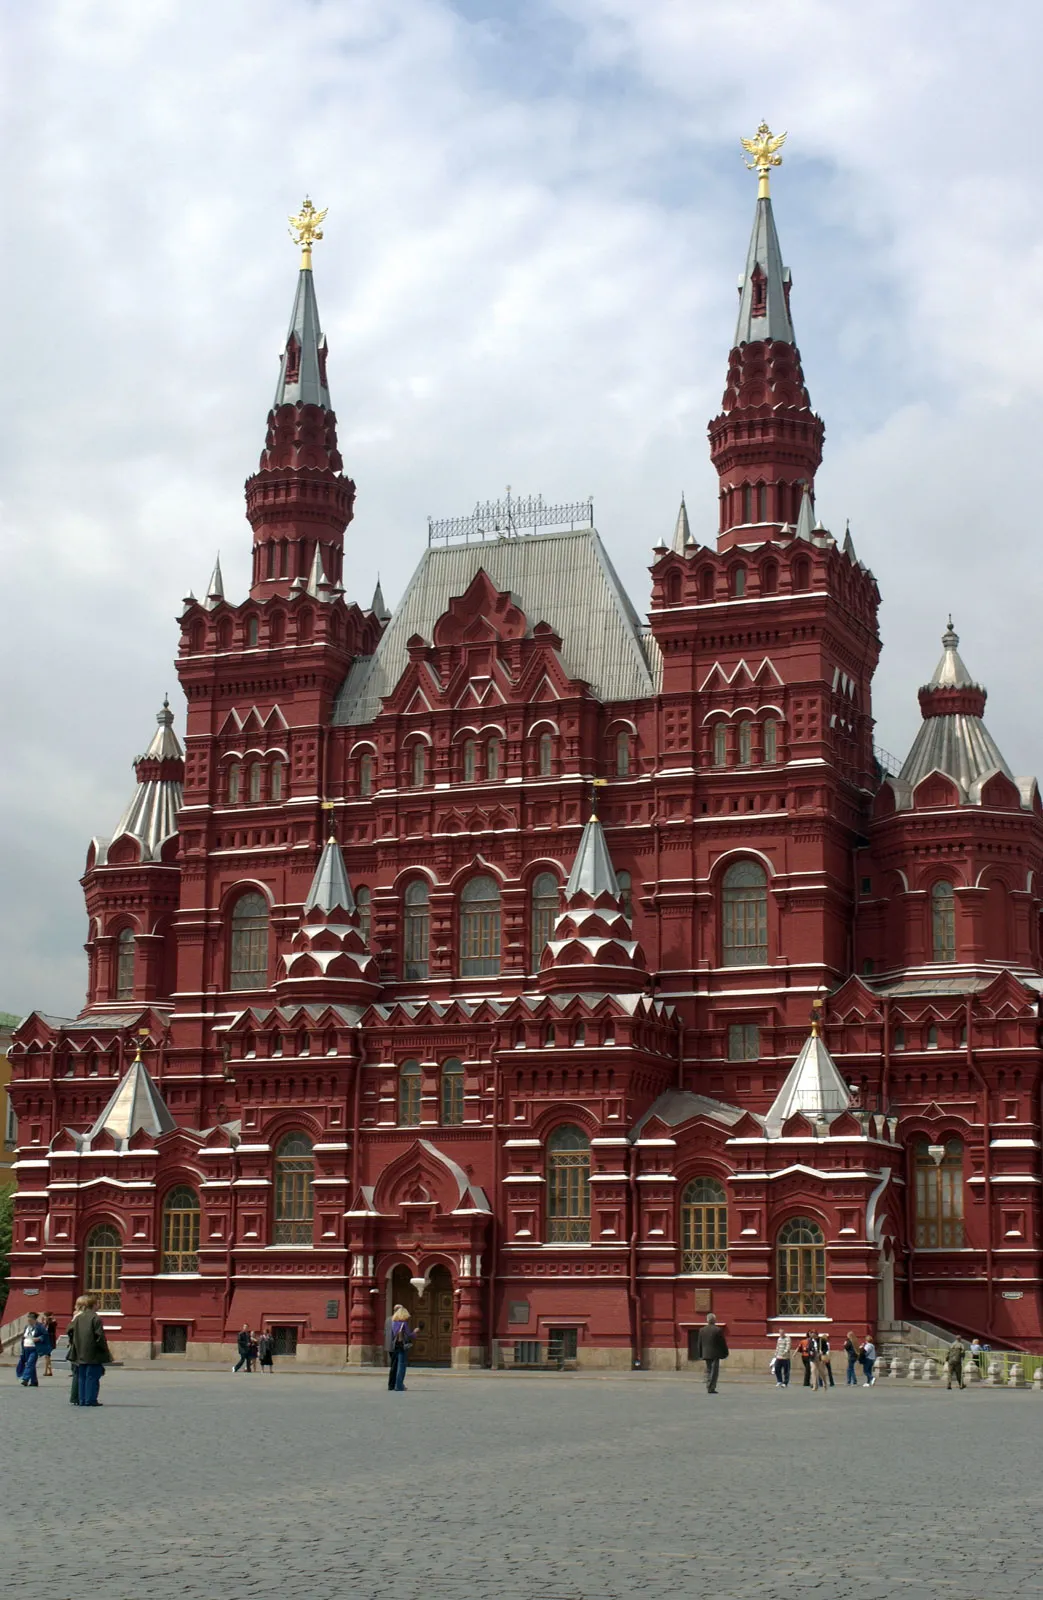What are some notable features of the architecture of the building shown in the image? The building showcases a Russian revival architectural style, characterized by its elaborate use of red brick and the intricate white decorative trim. Each tower and spire is intricately designed, contributing to the overall heritage aesthetic. Noteworthy features include the multi-tiered towers and the decorative arches above the windows and doors, which are typical of traditional Russian design motifs. 